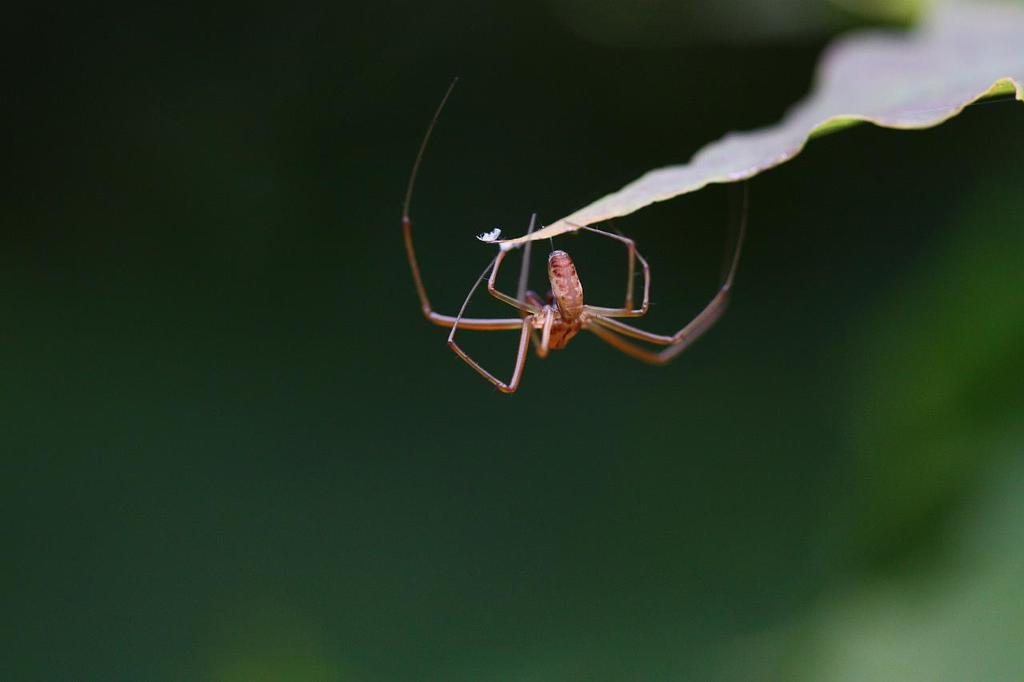What is the main subject of the image? The main subject of the image is a leaf. Is there anything else on the leaf? Yes, a spider is present on the leaf. How would you describe the background of the image? The background of the image is blurred and green in color. What type of acoustics can be heard coming from the spider's web in the image? There is no sound or acoustics associated with the spider's web in the image. How many pins are visible on the leaf in the image? There are no pins present in the image; it only features a leaf and a spider. 